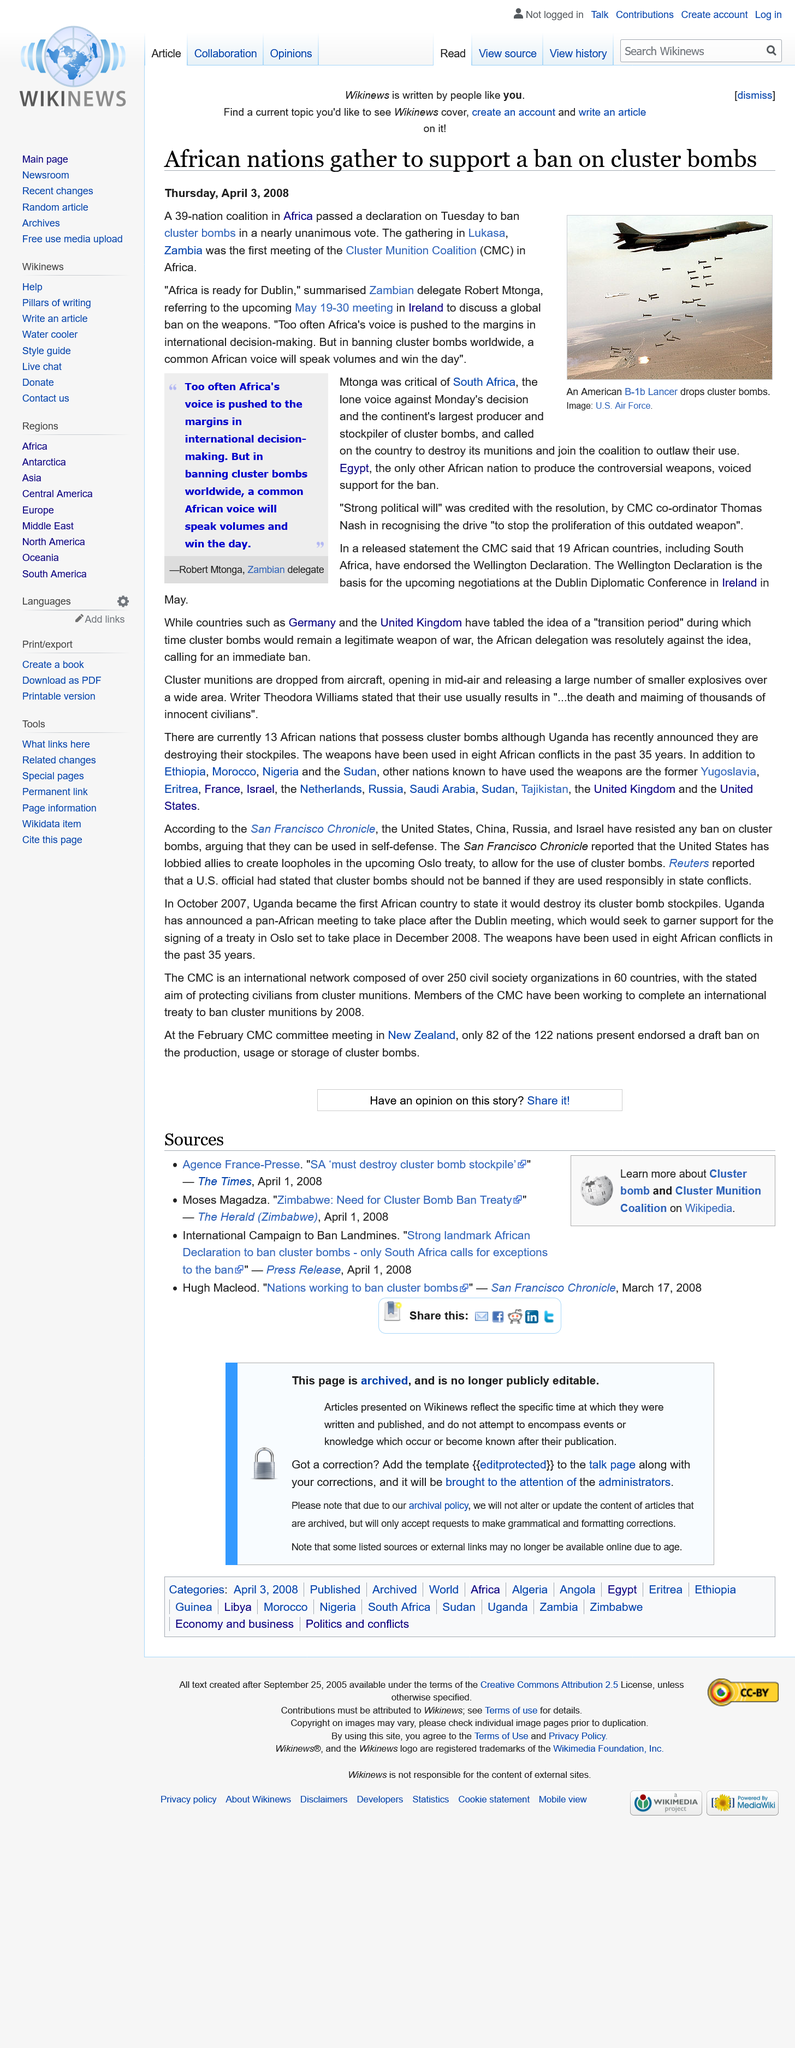Indicate a few pertinent items in this graphic. Nineteen African countries have endorsed the Wellington Declaration. Thirty-nine African nations have united in their support for a ban on cluster bombs. The B-1b Lancer is the name of the aircraft depicted in the image. 